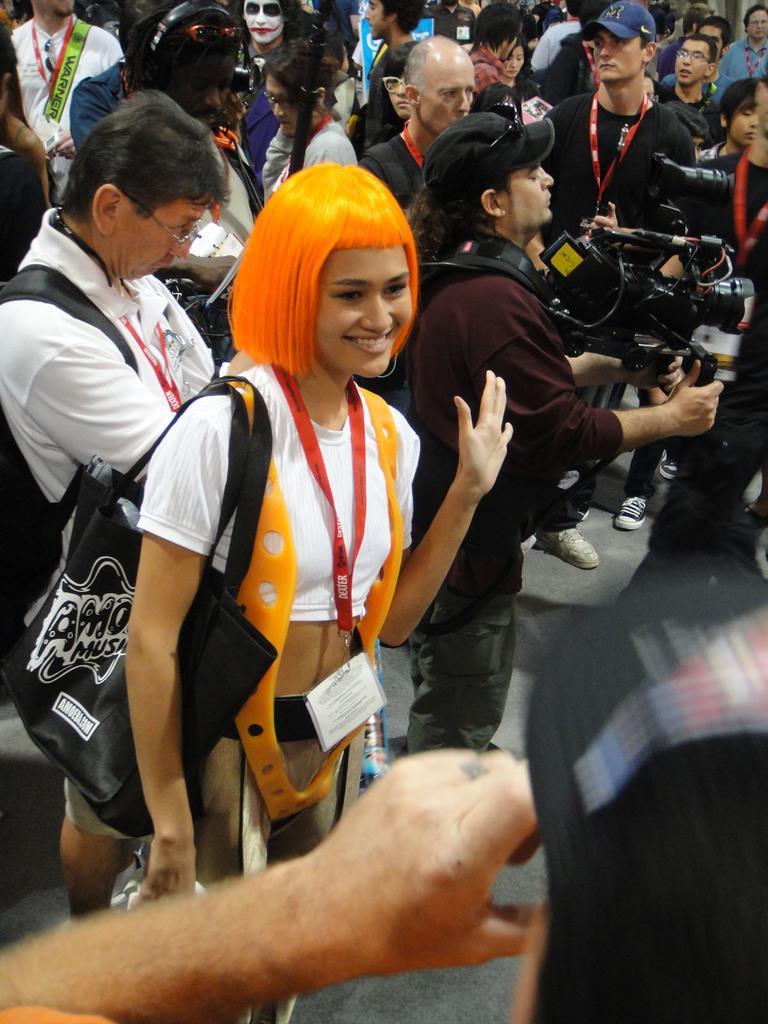Could you give a brief overview of what you see in this image? In this image we can see many people and a person on the right side holding a video camera. 